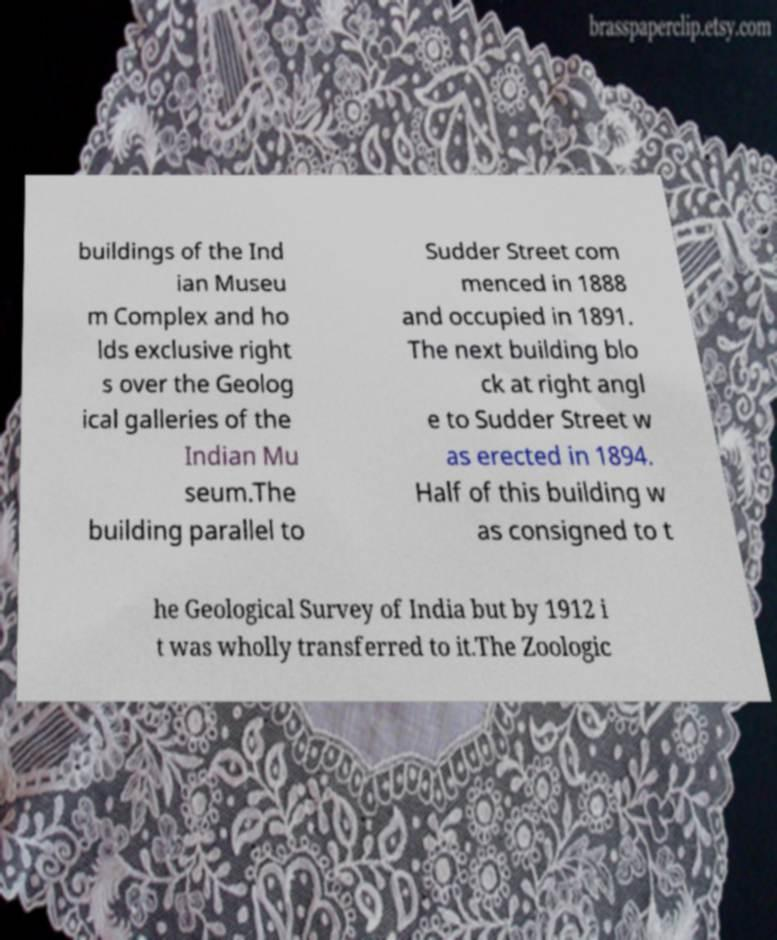Could you assist in decoding the text presented in this image and type it out clearly? buildings of the Ind ian Museu m Complex and ho lds exclusive right s over the Geolog ical galleries of the Indian Mu seum.The building parallel to Sudder Street com menced in 1888 and occupied in 1891. The next building blo ck at right angl e to Sudder Street w as erected in 1894. Half of this building w as consigned to t he Geological Survey of India but by 1912 i t was wholly transferred to it.The Zoologic 